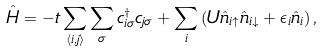Convert formula to latex. <formula><loc_0><loc_0><loc_500><loc_500>\hat { H } = - t \sum _ { \langle i , j \rangle } \sum _ { \sigma } c ^ { \dagger } _ { i \sigma } c _ { j \sigma } + \sum _ { i } \left ( U \hat { n } _ { i \uparrow } \hat { n } _ { i \downarrow } + \epsilon _ { i } \hat { n } _ { i } \right ) ,</formula> 